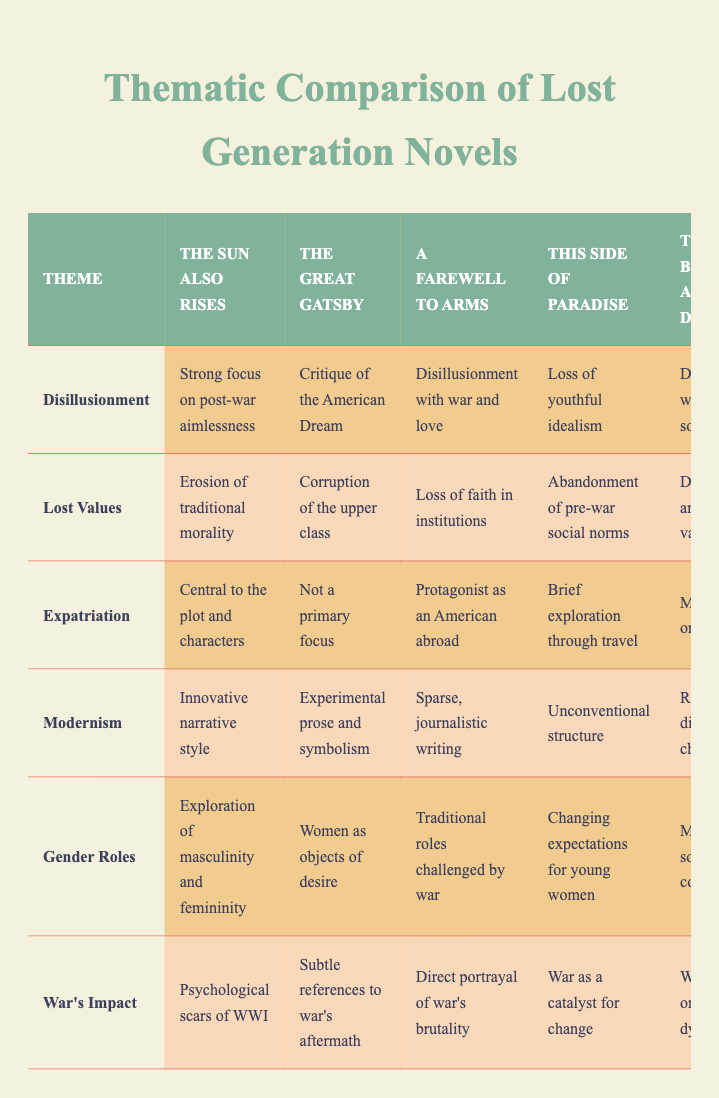What is the focus of disillusionment in "The Sun Also Rises"? The table states that "The Sun Also Rises" has a "Strong focus on post-war aimlessness" regarding the theme of disillusionment.
Answer: Strong focus on post-war aimlessness Which novel includes a critique of the American Dream under the theme of disillusionment? According to the table, "The Great Gatsby" contains a "Critique of the American Dream" in the context of disillusionment.
Answer: The Great Gatsby Does "A Farewell to Arms" focus heavily on expatriation? The table indicates that "A Farewell to Arms" describes "Protagonist as an American abroad," which suggests a notable focus on expatriation, but does not label it as central to the plot.
Answer: No Which two novels address the theme of lost values through a critique of societal norms? The table highlights that "The Sun Also Rises" discusses the "Erosion of traditional morality" and "The Beautiful and Damned" presents the "Decay of aristocratic values." Both point to societal critiques under lost values.
Answer: The Sun Also Rises and The Beautiful and Damned What is the relationship between war's impact and gender roles in "A Farewell to Arms"? In "A Farewell to Arms," the table shows that war challenges traditional roles, indicating that the impact of war leads to a reevaluation of gender roles.
Answer: War challenges traditional gender roles in "A Farewell to Arms" Which novel presents an innovative narrative style compared to the others? The table specifically notes that "The Sun Also Rises" features an "Innovative narrative style," distinguishing it from the other novels listed.
Answer: The Sun Also Rises How many novels address the theme of modernism, and what common aspect do they share? All five novels address modernism, showcasing two key aspects: innovative narrative techniques and experimental prose. The table confirms that each presents a different approach but remains under the same umbrella of modernism.
Answer: Five novels share innovative narrative techniques and experimental prose Is "This Side of Paradise" associated with a strong portrayal of war's impact? The table indicates that "This Side of Paradise" discusses "War as a catalyst for change," which implies that while it is related, it is not a strong portrayal compared to other novels like "A Farewell to Arms."
Answer: No 